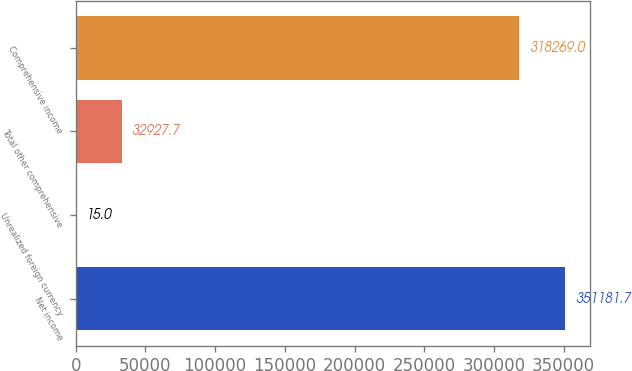<chart> <loc_0><loc_0><loc_500><loc_500><bar_chart><fcel>Net income<fcel>Unrealized foreign currency<fcel>Total other comprehensive<fcel>Comprehensive income<nl><fcel>351182<fcel>15<fcel>32927.7<fcel>318269<nl></chart> 